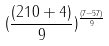<formula> <loc_0><loc_0><loc_500><loc_500>( \frac { ( 2 1 0 + 4 ) } { 9 } ) ^ { \frac { ( 7 - 5 7 ) } { 9 } }</formula> 